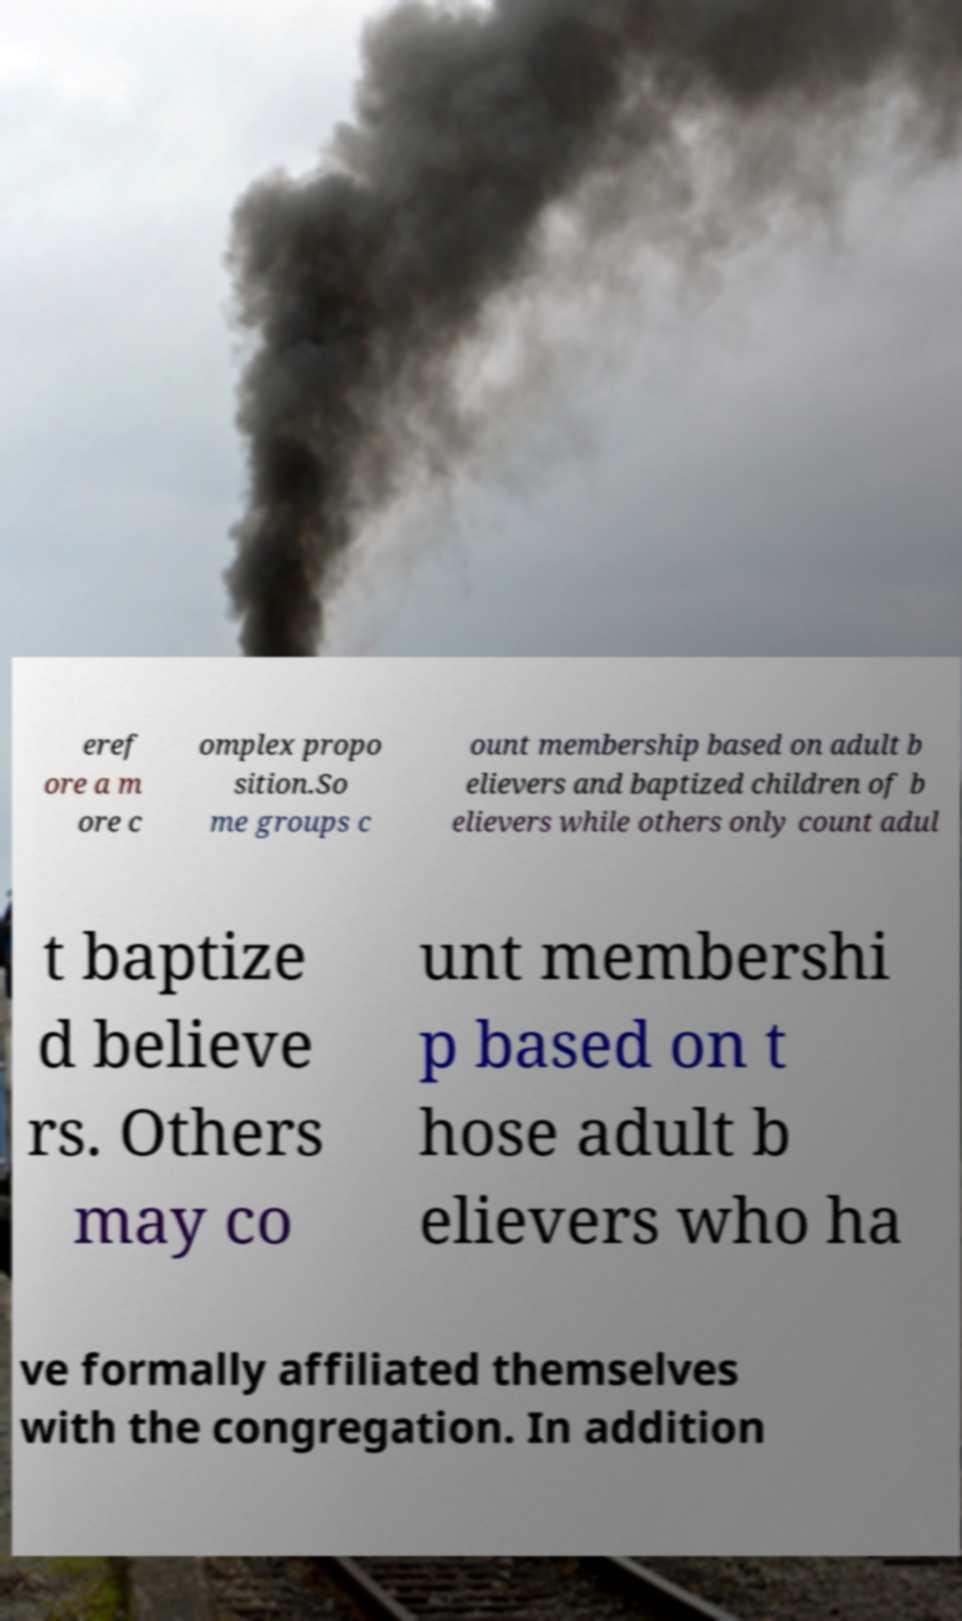Could you extract and type out the text from this image? eref ore a m ore c omplex propo sition.So me groups c ount membership based on adult b elievers and baptized children of b elievers while others only count adul t baptize d believe rs. Others may co unt membershi p based on t hose adult b elievers who ha ve formally affiliated themselves with the congregation. In addition 